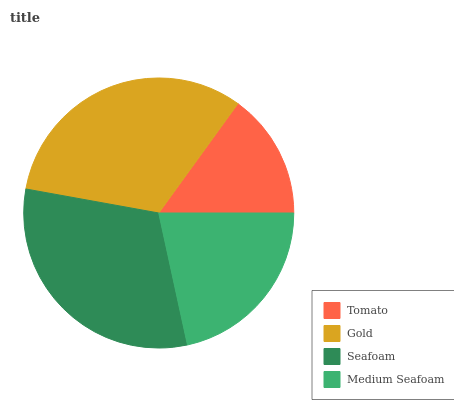Is Tomato the minimum?
Answer yes or no. Yes. Is Gold the maximum?
Answer yes or no. Yes. Is Seafoam the minimum?
Answer yes or no. No. Is Seafoam the maximum?
Answer yes or no. No. Is Gold greater than Seafoam?
Answer yes or no. Yes. Is Seafoam less than Gold?
Answer yes or no. Yes. Is Seafoam greater than Gold?
Answer yes or no. No. Is Gold less than Seafoam?
Answer yes or no. No. Is Seafoam the high median?
Answer yes or no. Yes. Is Medium Seafoam the low median?
Answer yes or no. Yes. Is Tomato the high median?
Answer yes or no. No. Is Seafoam the low median?
Answer yes or no. No. 